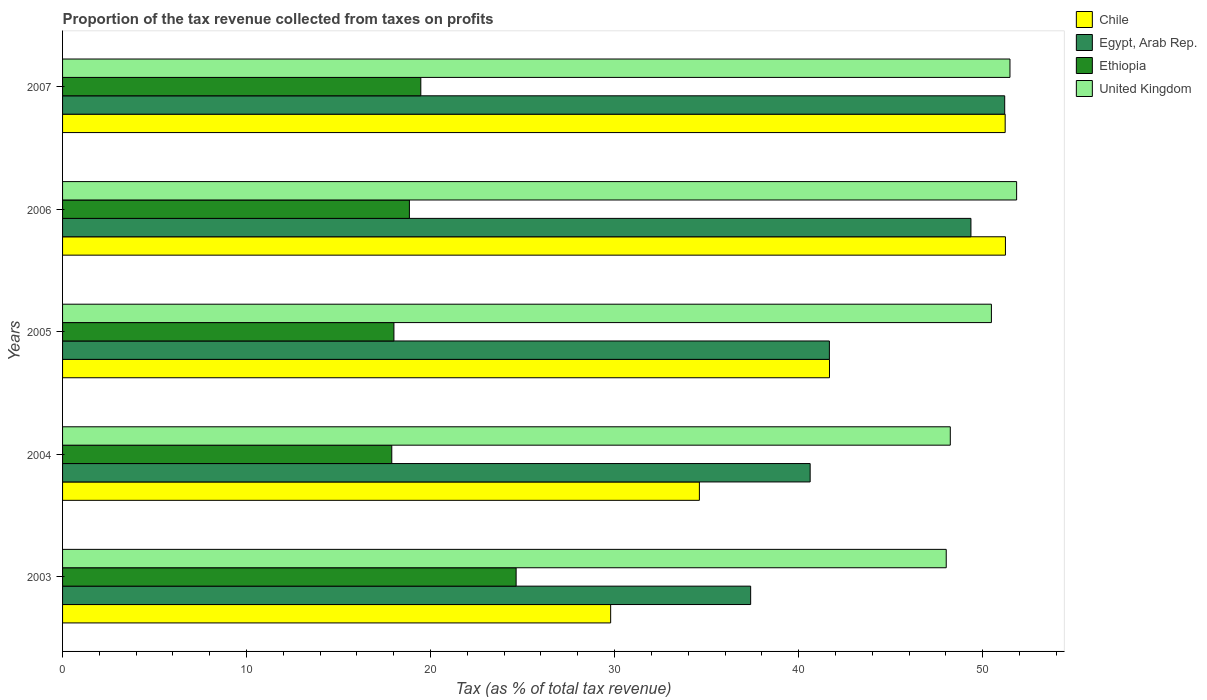How many groups of bars are there?
Your response must be concise. 5. Are the number of bars per tick equal to the number of legend labels?
Provide a short and direct response. Yes. Are the number of bars on each tick of the Y-axis equal?
Offer a terse response. Yes. How many bars are there on the 1st tick from the top?
Your response must be concise. 4. How many bars are there on the 2nd tick from the bottom?
Give a very brief answer. 4. What is the label of the 3rd group of bars from the top?
Make the answer very short. 2005. In how many cases, is the number of bars for a given year not equal to the number of legend labels?
Offer a terse response. 0. What is the proportion of the tax revenue collected in Egypt, Arab Rep. in 2004?
Offer a very short reply. 40.63. Across all years, what is the maximum proportion of the tax revenue collected in Ethiopia?
Offer a very short reply. 24.65. Across all years, what is the minimum proportion of the tax revenue collected in United Kingdom?
Offer a terse response. 48.02. In which year was the proportion of the tax revenue collected in United Kingdom minimum?
Provide a short and direct response. 2003. What is the total proportion of the tax revenue collected in Egypt, Arab Rep. in the graph?
Your response must be concise. 220.26. What is the difference between the proportion of the tax revenue collected in Egypt, Arab Rep. in 2003 and that in 2007?
Provide a short and direct response. -13.81. What is the difference between the proportion of the tax revenue collected in Chile in 2004 and the proportion of the tax revenue collected in Ethiopia in 2006?
Provide a succinct answer. 15.76. What is the average proportion of the tax revenue collected in Ethiopia per year?
Provide a short and direct response. 19.77. In the year 2005, what is the difference between the proportion of the tax revenue collected in Chile and proportion of the tax revenue collected in Egypt, Arab Rep.?
Provide a short and direct response. 0. What is the ratio of the proportion of the tax revenue collected in Chile in 2004 to that in 2006?
Give a very brief answer. 0.68. What is the difference between the highest and the second highest proportion of the tax revenue collected in United Kingdom?
Offer a terse response. 0.36. What is the difference between the highest and the lowest proportion of the tax revenue collected in Egypt, Arab Rep.?
Provide a short and direct response. 13.81. Is the sum of the proportion of the tax revenue collected in Egypt, Arab Rep. in 2003 and 2004 greater than the maximum proportion of the tax revenue collected in United Kingdom across all years?
Your answer should be compact. Yes. What does the 2nd bar from the top in 2006 represents?
Ensure brevity in your answer.  Ethiopia. Is it the case that in every year, the sum of the proportion of the tax revenue collected in Egypt, Arab Rep. and proportion of the tax revenue collected in United Kingdom is greater than the proportion of the tax revenue collected in Chile?
Offer a terse response. Yes. How many bars are there?
Offer a terse response. 20. Are all the bars in the graph horizontal?
Your response must be concise. Yes. What is the difference between two consecutive major ticks on the X-axis?
Keep it short and to the point. 10. How many legend labels are there?
Give a very brief answer. 4. How are the legend labels stacked?
Provide a succinct answer. Vertical. What is the title of the graph?
Offer a terse response. Proportion of the tax revenue collected from taxes on profits. What is the label or title of the X-axis?
Your answer should be very brief. Tax (as % of total tax revenue). What is the Tax (as % of total tax revenue) in Chile in 2003?
Your response must be concise. 29.79. What is the Tax (as % of total tax revenue) of Egypt, Arab Rep. in 2003?
Your answer should be compact. 37.39. What is the Tax (as % of total tax revenue) of Ethiopia in 2003?
Ensure brevity in your answer.  24.65. What is the Tax (as % of total tax revenue) of United Kingdom in 2003?
Keep it short and to the point. 48.02. What is the Tax (as % of total tax revenue) of Chile in 2004?
Ensure brevity in your answer.  34.61. What is the Tax (as % of total tax revenue) of Egypt, Arab Rep. in 2004?
Your answer should be very brief. 40.63. What is the Tax (as % of total tax revenue) in Ethiopia in 2004?
Your answer should be compact. 17.89. What is the Tax (as % of total tax revenue) in United Kingdom in 2004?
Provide a short and direct response. 48.24. What is the Tax (as % of total tax revenue) of Chile in 2005?
Offer a terse response. 41.68. What is the Tax (as % of total tax revenue) of Egypt, Arab Rep. in 2005?
Make the answer very short. 41.67. What is the Tax (as % of total tax revenue) of Ethiopia in 2005?
Provide a short and direct response. 18.01. What is the Tax (as % of total tax revenue) in United Kingdom in 2005?
Your response must be concise. 50.48. What is the Tax (as % of total tax revenue) in Chile in 2006?
Make the answer very short. 51.24. What is the Tax (as % of total tax revenue) in Egypt, Arab Rep. in 2006?
Your answer should be very brief. 49.37. What is the Tax (as % of total tax revenue) of Ethiopia in 2006?
Offer a very short reply. 18.85. What is the Tax (as % of total tax revenue) of United Kingdom in 2006?
Make the answer very short. 51.85. What is the Tax (as % of total tax revenue) of Chile in 2007?
Offer a very short reply. 51.23. What is the Tax (as % of total tax revenue) of Egypt, Arab Rep. in 2007?
Provide a succinct answer. 51.2. What is the Tax (as % of total tax revenue) of Ethiopia in 2007?
Your response must be concise. 19.47. What is the Tax (as % of total tax revenue) in United Kingdom in 2007?
Provide a short and direct response. 51.49. Across all years, what is the maximum Tax (as % of total tax revenue) in Chile?
Give a very brief answer. 51.24. Across all years, what is the maximum Tax (as % of total tax revenue) in Egypt, Arab Rep.?
Ensure brevity in your answer.  51.2. Across all years, what is the maximum Tax (as % of total tax revenue) in Ethiopia?
Ensure brevity in your answer.  24.65. Across all years, what is the maximum Tax (as % of total tax revenue) of United Kingdom?
Offer a very short reply. 51.85. Across all years, what is the minimum Tax (as % of total tax revenue) in Chile?
Give a very brief answer. 29.79. Across all years, what is the minimum Tax (as % of total tax revenue) in Egypt, Arab Rep.?
Keep it short and to the point. 37.39. Across all years, what is the minimum Tax (as % of total tax revenue) in Ethiopia?
Your response must be concise. 17.89. Across all years, what is the minimum Tax (as % of total tax revenue) of United Kingdom?
Ensure brevity in your answer.  48.02. What is the total Tax (as % of total tax revenue) in Chile in the graph?
Keep it short and to the point. 208.54. What is the total Tax (as % of total tax revenue) in Egypt, Arab Rep. in the graph?
Your answer should be compact. 220.26. What is the total Tax (as % of total tax revenue) of Ethiopia in the graph?
Offer a terse response. 98.86. What is the total Tax (as % of total tax revenue) in United Kingdom in the graph?
Your response must be concise. 250.08. What is the difference between the Tax (as % of total tax revenue) of Chile in 2003 and that in 2004?
Provide a succinct answer. -4.82. What is the difference between the Tax (as % of total tax revenue) of Egypt, Arab Rep. in 2003 and that in 2004?
Give a very brief answer. -3.23. What is the difference between the Tax (as % of total tax revenue) in Ethiopia in 2003 and that in 2004?
Your answer should be compact. 6.76. What is the difference between the Tax (as % of total tax revenue) of United Kingdom in 2003 and that in 2004?
Offer a very short reply. -0.22. What is the difference between the Tax (as % of total tax revenue) of Chile in 2003 and that in 2005?
Keep it short and to the point. -11.89. What is the difference between the Tax (as % of total tax revenue) in Egypt, Arab Rep. in 2003 and that in 2005?
Give a very brief answer. -4.28. What is the difference between the Tax (as % of total tax revenue) in Ethiopia in 2003 and that in 2005?
Keep it short and to the point. 6.64. What is the difference between the Tax (as % of total tax revenue) of United Kingdom in 2003 and that in 2005?
Your answer should be compact. -2.46. What is the difference between the Tax (as % of total tax revenue) of Chile in 2003 and that in 2006?
Offer a very short reply. -21.45. What is the difference between the Tax (as % of total tax revenue) in Egypt, Arab Rep. in 2003 and that in 2006?
Make the answer very short. -11.97. What is the difference between the Tax (as % of total tax revenue) in Ethiopia in 2003 and that in 2006?
Your response must be concise. 5.8. What is the difference between the Tax (as % of total tax revenue) of United Kingdom in 2003 and that in 2006?
Provide a short and direct response. -3.83. What is the difference between the Tax (as % of total tax revenue) of Chile in 2003 and that in 2007?
Give a very brief answer. -21.44. What is the difference between the Tax (as % of total tax revenue) in Egypt, Arab Rep. in 2003 and that in 2007?
Your answer should be compact. -13.81. What is the difference between the Tax (as % of total tax revenue) in Ethiopia in 2003 and that in 2007?
Give a very brief answer. 5.18. What is the difference between the Tax (as % of total tax revenue) of United Kingdom in 2003 and that in 2007?
Offer a terse response. -3.46. What is the difference between the Tax (as % of total tax revenue) of Chile in 2004 and that in 2005?
Make the answer very short. -7.07. What is the difference between the Tax (as % of total tax revenue) in Egypt, Arab Rep. in 2004 and that in 2005?
Offer a terse response. -1.05. What is the difference between the Tax (as % of total tax revenue) of Ethiopia in 2004 and that in 2005?
Offer a very short reply. -0.12. What is the difference between the Tax (as % of total tax revenue) of United Kingdom in 2004 and that in 2005?
Offer a terse response. -2.23. What is the difference between the Tax (as % of total tax revenue) of Chile in 2004 and that in 2006?
Offer a very short reply. -16.63. What is the difference between the Tax (as % of total tax revenue) of Egypt, Arab Rep. in 2004 and that in 2006?
Give a very brief answer. -8.74. What is the difference between the Tax (as % of total tax revenue) of Ethiopia in 2004 and that in 2006?
Offer a terse response. -0.96. What is the difference between the Tax (as % of total tax revenue) in United Kingdom in 2004 and that in 2006?
Provide a short and direct response. -3.61. What is the difference between the Tax (as % of total tax revenue) of Chile in 2004 and that in 2007?
Your answer should be compact. -16.62. What is the difference between the Tax (as % of total tax revenue) in Egypt, Arab Rep. in 2004 and that in 2007?
Offer a very short reply. -10.57. What is the difference between the Tax (as % of total tax revenue) of Ethiopia in 2004 and that in 2007?
Provide a succinct answer. -1.58. What is the difference between the Tax (as % of total tax revenue) of United Kingdom in 2004 and that in 2007?
Your response must be concise. -3.24. What is the difference between the Tax (as % of total tax revenue) in Chile in 2005 and that in 2006?
Keep it short and to the point. -9.56. What is the difference between the Tax (as % of total tax revenue) in Egypt, Arab Rep. in 2005 and that in 2006?
Offer a very short reply. -7.69. What is the difference between the Tax (as % of total tax revenue) of Ethiopia in 2005 and that in 2006?
Your answer should be very brief. -0.84. What is the difference between the Tax (as % of total tax revenue) in United Kingdom in 2005 and that in 2006?
Make the answer very short. -1.37. What is the difference between the Tax (as % of total tax revenue) in Chile in 2005 and that in 2007?
Provide a succinct answer. -9.55. What is the difference between the Tax (as % of total tax revenue) of Egypt, Arab Rep. in 2005 and that in 2007?
Provide a succinct answer. -9.53. What is the difference between the Tax (as % of total tax revenue) in Ethiopia in 2005 and that in 2007?
Make the answer very short. -1.46. What is the difference between the Tax (as % of total tax revenue) in United Kingdom in 2005 and that in 2007?
Give a very brief answer. -1.01. What is the difference between the Tax (as % of total tax revenue) of Chile in 2006 and that in 2007?
Provide a short and direct response. 0.01. What is the difference between the Tax (as % of total tax revenue) of Egypt, Arab Rep. in 2006 and that in 2007?
Give a very brief answer. -1.84. What is the difference between the Tax (as % of total tax revenue) in Ethiopia in 2006 and that in 2007?
Your answer should be very brief. -0.62. What is the difference between the Tax (as % of total tax revenue) of United Kingdom in 2006 and that in 2007?
Your answer should be compact. 0.36. What is the difference between the Tax (as % of total tax revenue) of Chile in 2003 and the Tax (as % of total tax revenue) of Egypt, Arab Rep. in 2004?
Make the answer very short. -10.84. What is the difference between the Tax (as % of total tax revenue) in Chile in 2003 and the Tax (as % of total tax revenue) in Ethiopia in 2004?
Provide a succinct answer. 11.89. What is the difference between the Tax (as % of total tax revenue) of Chile in 2003 and the Tax (as % of total tax revenue) of United Kingdom in 2004?
Your answer should be very brief. -18.46. What is the difference between the Tax (as % of total tax revenue) of Egypt, Arab Rep. in 2003 and the Tax (as % of total tax revenue) of Ethiopia in 2004?
Make the answer very short. 19.5. What is the difference between the Tax (as % of total tax revenue) of Egypt, Arab Rep. in 2003 and the Tax (as % of total tax revenue) of United Kingdom in 2004?
Provide a succinct answer. -10.85. What is the difference between the Tax (as % of total tax revenue) of Ethiopia in 2003 and the Tax (as % of total tax revenue) of United Kingdom in 2004?
Offer a terse response. -23.6. What is the difference between the Tax (as % of total tax revenue) of Chile in 2003 and the Tax (as % of total tax revenue) of Egypt, Arab Rep. in 2005?
Your answer should be very brief. -11.89. What is the difference between the Tax (as % of total tax revenue) in Chile in 2003 and the Tax (as % of total tax revenue) in Ethiopia in 2005?
Offer a very short reply. 11.78. What is the difference between the Tax (as % of total tax revenue) of Chile in 2003 and the Tax (as % of total tax revenue) of United Kingdom in 2005?
Keep it short and to the point. -20.69. What is the difference between the Tax (as % of total tax revenue) in Egypt, Arab Rep. in 2003 and the Tax (as % of total tax revenue) in Ethiopia in 2005?
Give a very brief answer. 19.39. What is the difference between the Tax (as % of total tax revenue) of Egypt, Arab Rep. in 2003 and the Tax (as % of total tax revenue) of United Kingdom in 2005?
Your answer should be very brief. -13.08. What is the difference between the Tax (as % of total tax revenue) in Ethiopia in 2003 and the Tax (as % of total tax revenue) in United Kingdom in 2005?
Your response must be concise. -25.83. What is the difference between the Tax (as % of total tax revenue) of Chile in 2003 and the Tax (as % of total tax revenue) of Egypt, Arab Rep. in 2006?
Your answer should be compact. -19.58. What is the difference between the Tax (as % of total tax revenue) of Chile in 2003 and the Tax (as % of total tax revenue) of Ethiopia in 2006?
Make the answer very short. 10.94. What is the difference between the Tax (as % of total tax revenue) of Chile in 2003 and the Tax (as % of total tax revenue) of United Kingdom in 2006?
Make the answer very short. -22.06. What is the difference between the Tax (as % of total tax revenue) of Egypt, Arab Rep. in 2003 and the Tax (as % of total tax revenue) of Ethiopia in 2006?
Your answer should be compact. 18.55. What is the difference between the Tax (as % of total tax revenue) in Egypt, Arab Rep. in 2003 and the Tax (as % of total tax revenue) in United Kingdom in 2006?
Offer a terse response. -14.45. What is the difference between the Tax (as % of total tax revenue) in Ethiopia in 2003 and the Tax (as % of total tax revenue) in United Kingdom in 2006?
Ensure brevity in your answer.  -27.2. What is the difference between the Tax (as % of total tax revenue) of Chile in 2003 and the Tax (as % of total tax revenue) of Egypt, Arab Rep. in 2007?
Ensure brevity in your answer.  -21.41. What is the difference between the Tax (as % of total tax revenue) of Chile in 2003 and the Tax (as % of total tax revenue) of Ethiopia in 2007?
Your answer should be very brief. 10.32. What is the difference between the Tax (as % of total tax revenue) of Chile in 2003 and the Tax (as % of total tax revenue) of United Kingdom in 2007?
Keep it short and to the point. -21.7. What is the difference between the Tax (as % of total tax revenue) in Egypt, Arab Rep. in 2003 and the Tax (as % of total tax revenue) in Ethiopia in 2007?
Your answer should be very brief. 17.93. What is the difference between the Tax (as % of total tax revenue) of Egypt, Arab Rep. in 2003 and the Tax (as % of total tax revenue) of United Kingdom in 2007?
Offer a very short reply. -14.09. What is the difference between the Tax (as % of total tax revenue) in Ethiopia in 2003 and the Tax (as % of total tax revenue) in United Kingdom in 2007?
Your answer should be very brief. -26.84. What is the difference between the Tax (as % of total tax revenue) of Chile in 2004 and the Tax (as % of total tax revenue) of Egypt, Arab Rep. in 2005?
Make the answer very short. -7.06. What is the difference between the Tax (as % of total tax revenue) in Chile in 2004 and the Tax (as % of total tax revenue) in Ethiopia in 2005?
Provide a short and direct response. 16.6. What is the difference between the Tax (as % of total tax revenue) of Chile in 2004 and the Tax (as % of total tax revenue) of United Kingdom in 2005?
Ensure brevity in your answer.  -15.87. What is the difference between the Tax (as % of total tax revenue) in Egypt, Arab Rep. in 2004 and the Tax (as % of total tax revenue) in Ethiopia in 2005?
Your answer should be compact. 22.62. What is the difference between the Tax (as % of total tax revenue) in Egypt, Arab Rep. in 2004 and the Tax (as % of total tax revenue) in United Kingdom in 2005?
Ensure brevity in your answer.  -9.85. What is the difference between the Tax (as % of total tax revenue) of Ethiopia in 2004 and the Tax (as % of total tax revenue) of United Kingdom in 2005?
Ensure brevity in your answer.  -32.59. What is the difference between the Tax (as % of total tax revenue) of Chile in 2004 and the Tax (as % of total tax revenue) of Egypt, Arab Rep. in 2006?
Ensure brevity in your answer.  -14.76. What is the difference between the Tax (as % of total tax revenue) of Chile in 2004 and the Tax (as % of total tax revenue) of Ethiopia in 2006?
Your answer should be very brief. 15.76. What is the difference between the Tax (as % of total tax revenue) in Chile in 2004 and the Tax (as % of total tax revenue) in United Kingdom in 2006?
Give a very brief answer. -17.24. What is the difference between the Tax (as % of total tax revenue) of Egypt, Arab Rep. in 2004 and the Tax (as % of total tax revenue) of Ethiopia in 2006?
Offer a terse response. 21.78. What is the difference between the Tax (as % of total tax revenue) in Egypt, Arab Rep. in 2004 and the Tax (as % of total tax revenue) in United Kingdom in 2006?
Your answer should be very brief. -11.22. What is the difference between the Tax (as % of total tax revenue) of Ethiopia in 2004 and the Tax (as % of total tax revenue) of United Kingdom in 2006?
Keep it short and to the point. -33.96. What is the difference between the Tax (as % of total tax revenue) in Chile in 2004 and the Tax (as % of total tax revenue) in Egypt, Arab Rep. in 2007?
Offer a terse response. -16.59. What is the difference between the Tax (as % of total tax revenue) in Chile in 2004 and the Tax (as % of total tax revenue) in Ethiopia in 2007?
Make the answer very short. 15.14. What is the difference between the Tax (as % of total tax revenue) in Chile in 2004 and the Tax (as % of total tax revenue) in United Kingdom in 2007?
Your response must be concise. -16.88. What is the difference between the Tax (as % of total tax revenue) in Egypt, Arab Rep. in 2004 and the Tax (as % of total tax revenue) in Ethiopia in 2007?
Provide a short and direct response. 21.16. What is the difference between the Tax (as % of total tax revenue) in Egypt, Arab Rep. in 2004 and the Tax (as % of total tax revenue) in United Kingdom in 2007?
Ensure brevity in your answer.  -10.86. What is the difference between the Tax (as % of total tax revenue) of Ethiopia in 2004 and the Tax (as % of total tax revenue) of United Kingdom in 2007?
Make the answer very short. -33.59. What is the difference between the Tax (as % of total tax revenue) in Chile in 2005 and the Tax (as % of total tax revenue) in Egypt, Arab Rep. in 2006?
Ensure brevity in your answer.  -7.69. What is the difference between the Tax (as % of total tax revenue) in Chile in 2005 and the Tax (as % of total tax revenue) in Ethiopia in 2006?
Provide a succinct answer. 22.83. What is the difference between the Tax (as % of total tax revenue) in Chile in 2005 and the Tax (as % of total tax revenue) in United Kingdom in 2006?
Offer a terse response. -10.17. What is the difference between the Tax (as % of total tax revenue) in Egypt, Arab Rep. in 2005 and the Tax (as % of total tax revenue) in Ethiopia in 2006?
Your answer should be very brief. 22.82. What is the difference between the Tax (as % of total tax revenue) in Egypt, Arab Rep. in 2005 and the Tax (as % of total tax revenue) in United Kingdom in 2006?
Ensure brevity in your answer.  -10.18. What is the difference between the Tax (as % of total tax revenue) of Ethiopia in 2005 and the Tax (as % of total tax revenue) of United Kingdom in 2006?
Provide a short and direct response. -33.84. What is the difference between the Tax (as % of total tax revenue) of Chile in 2005 and the Tax (as % of total tax revenue) of Egypt, Arab Rep. in 2007?
Offer a very short reply. -9.52. What is the difference between the Tax (as % of total tax revenue) in Chile in 2005 and the Tax (as % of total tax revenue) in Ethiopia in 2007?
Your response must be concise. 22.21. What is the difference between the Tax (as % of total tax revenue) of Chile in 2005 and the Tax (as % of total tax revenue) of United Kingdom in 2007?
Keep it short and to the point. -9.81. What is the difference between the Tax (as % of total tax revenue) in Egypt, Arab Rep. in 2005 and the Tax (as % of total tax revenue) in Ethiopia in 2007?
Offer a terse response. 22.2. What is the difference between the Tax (as % of total tax revenue) in Egypt, Arab Rep. in 2005 and the Tax (as % of total tax revenue) in United Kingdom in 2007?
Give a very brief answer. -9.81. What is the difference between the Tax (as % of total tax revenue) of Ethiopia in 2005 and the Tax (as % of total tax revenue) of United Kingdom in 2007?
Offer a terse response. -33.48. What is the difference between the Tax (as % of total tax revenue) in Chile in 2006 and the Tax (as % of total tax revenue) in Egypt, Arab Rep. in 2007?
Keep it short and to the point. 0.04. What is the difference between the Tax (as % of total tax revenue) in Chile in 2006 and the Tax (as % of total tax revenue) in Ethiopia in 2007?
Ensure brevity in your answer.  31.77. What is the difference between the Tax (as % of total tax revenue) in Chile in 2006 and the Tax (as % of total tax revenue) in United Kingdom in 2007?
Provide a short and direct response. -0.25. What is the difference between the Tax (as % of total tax revenue) of Egypt, Arab Rep. in 2006 and the Tax (as % of total tax revenue) of Ethiopia in 2007?
Provide a succinct answer. 29.9. What is the difference between the Tax (as % of total tax revenue) in Egypt, Arab Rep. in 2006 and the Tax (as % of total tax revenue) in United Kingdom in 2007?
Provide a short and direct response. -2.12. What is the difference between the Tax (as % of total tax revenue) in Ethiopia in 2006 and the Tax (as % of total tax revenue) in United Kingdom in 2007?
Provide a succinct answer. -32.64. What is the average Tax (as % of total tax revenue) in Chile per year?
Provide a succinct answer. 41.71. What is the average Tax (as % of total tax revenue) in Egypt, Arab Rep. per year?
Give a very brief answer. 44.05. What is the average Tax (as % of total tax revenue) of Ethiopia per year?
Your response must be concise. 19.77. What is the average Tax (as % of total tax revenue) in United Kingdom per year?
Offer a very short reply. 50.02. In the year 2003, what is the difference between the Tax (as % of total tax revenue) in Chile and Tax (as % of total tax revenue) in Egypt, Arab Rep.?
Offer a terse response. -7.61. In the year 2003, what is the difference between the Tax (as % of total tax revenue) of Chile and Tax (as % of total tax revenue) of Ethiopia?
Your response must be concise. 5.14. In the year 2003, what is the difference between the Tax (as % of total tax revenue) in Chile and Tax (as % of total tax revenue) in United Kingdom?
Offer a terse response. -18.24. In the year 2003, what is the difference between the Tax (as % of total tax revenue) of Egypt, Arab Rep. and Tax (as % of total tax revenue) of Ethiopia?
Keep it short and to the point. 12.75. In the year 2003, what is the difference between the Tax (as % of total tax revenue) in Egypt, Arab Rep. and Tax (as % of total tax revenue) in United Kingdom?
Your answer should be very brief. -10.63. In the year 2003, what is the difference between the Tax (as % of total tax revenue) of Ethiopia and Tax (as % of total tax revenue) of United Kingdom?
Your response must be concise. -23.37. In the year 2004, what is the difference between the Tax (as % of total tax revenue) of Chile and Tax (as % of total tax revenue) of Egypt, Arab Rep.?
Make the answer very short. -6.02. In the year 2004, what is the difference between the Tax (as % of total tax revenue) in Chile and Tax (as % of total tax revenue) in Ethiopia?
Ensure brevity in your answer.  16.72. In the year 2004, what is the difference between the Tax (as % of total tax revenue) of Chile and Tax (as % of total tax revenue) of United Kingdom?
Provide a short and direct response. -13.64. In the year 2004, what is the difference between the Tax (as % of total tax revenue) in Egypt, Arab Rep. and Tax (as % of total tax revenue) in Ethiopia?
Make the answer very short. 22.74. In the year 2004, what is the difference between the Tax (as % of total tax revenue) in Egypt, Arab Rep. and Tax (as % of total tax revenue) in United Kingdom?
Offer a very short reply. -7.62. In the year 2004, what is the difference between the Tax (as % of total tax revenue) of Ethiopia and Tax (as % of total tax revenue) of United Kingdom?
Your response must be concise. -30.35. In the year 2005, what is the difference between the Tax (as % of total tax revenue) of Chile and Tax (as % of total tax revenue) of Egypt, Arab Rep.?
Provide a short and direct response. 0.01. In the year 2005, what is the difference between the Tax (as % of total tax revenue) in Chile and Tax (as % of total tax revenue) in Ethiopia?
Provide a succinct answer. 23.67. In the year 2005, what is the difference between the Tax (as % of total tax revenue) in Chile and Tax (as % of total tax revenue) in United Kingdom?
Make the answer very short. -8.8. In the year 2005, what is the difference between the Tax (as % of total tax revenue) of Egypt, Arab Rep. and Tax (as % of total tax revenue) of Ethiopia?
Your answer should be compact. 23.67. In the year 2005, what is the difference between the Tax (as % of total tax revenue) of Egypt, Arab Rep. and Tax (as % of total tax revenue) of United Kingdom?
Make the answer very short. -8.8. In the year 2005, what is the difference between the Tax (as % of total tax revenue) of Ethiopia and Tax (as % of total tax revenue) of United Kingdom?
Your answer should be very brief. -32.47. In the year 2006, what is the difference between the Tax (as % of total tax revenue) of Chile and Tax (as % of total tax revenue) of Egypt, Arab Rep.?
Provide a short and direct response. 1.88. In the year 2006, what is the difference between the Tax (as % of total tax revenue) in Chile and Tax (as % of total tax revenue) in Ethiopia?
Ensure brevity in your answer.  32.39. In the year 2006, what is the difference between the Tax (as % of total tax revenue) in Chile and Tax (as % of total tax revenue) in United Kingdom?
Your answer should be very brief. -0.61. In the year 2006, what is the difference between the Tax (as % of total tax revenue) in Egypt, Arab Rep. and Tax (as % of total tax revenue) in Ethiopia?
Provide a short and direct response. 30.52. In the year 2006, what is the difference between the Tax (as % of total tax revenue) of Egypt, Arab Rep. and Tax (as % of total tax revenue) of United Kingdom?
Give a very brief answer. -2.48. In the year 2006, what is the difference between the Tax (as % of total tax revenue) in Ethiopia and Tax (as % of total tax revenue) in United Kingdom?
Make the answer very short. -33. In the year 2007, what is the difference between the Tax (as % of total tax revenue) in Chile and Tax (as % of total tax revenue) in Egypt, Arab Rep.?
Give a very brief answer. 0.03. In the year 2007, what is the difference between the Tax (as % of total tax revenue) of Chile and Tax (as % of total tax revenue) of Ethiopia?
Keep it short and to the point. 31.76. In the year 2007, what is the difference between the Tax (as % of total tax revenue) of Chile and Tax (as % of total tax revenue) of United Kingdom?
Your response must be concise. -0.26. In the year 2007, what is the difference between the Tax (as % of total tax revenue) of Egypt, Arab Rep. and Tax (as % of total tax revenue) of Ethiopia?
Keep it short and to the point. 31.73. In the year 2007, what is the difference between the Tax (as % of total tax revenue) in Egypt, Arab Rep. and Tax (as % of total tax revenue) in United Kingdom?
Make the answer very short. -0.29. In the year 2007, what is the difference between the Tax (as % of total tax revenue) of Ethiopia and Tax (as % of total tax revenue) of United Kingdom?
Ensure brevity in your answer.  -32.02. What is the ratio of the Tax (as % of total tax revenue) in Chile in 2003 to that in 2004?
Keep it short and to the point. 0.86. What is the ratio of the Tax (as % of total tax revenue) of Egypt, Arab Rep. in 2003 to that in 2004?
Your answer should be compact. 0.92. What is the ratio of the Tax (as % of total tax revenue) in Ethiopia in 2003 to that in 2004?
Provide a succinct answer. 1.38. What is the ratio of the Tax (as % of total tax revenue) of United Kingdom in 2003 to that in 2004?
Your response must be concise. 1. What is the ratio of the Tax (as % of total tax revenue) in Chile in 2003 to that in 2005?
Offer a very short reply. 0.71. What is the ratio of the Tax (as % of total tax revenue) in Egypt, Arab Rep. in 2003 to that in 2005?
Offer a terse response. 0.9. What is the ratio of the Tax (as % of total tax revenue) in Ethiopia in 2003 to that in 2005?
Make the answer very short. 1.37. What is the ratio of the Tax (as % of total tax revenue) of United Kingdom in 2003 to that in 2005?
Provide a succinct answer. 0.95. What is the ratio of the Tax (as % of total tax revenue) of Chile in 2003 to that in 2006?
Provide a short and direct response. 0.58. What is the ratio of the Tax (as % of total tax revenue) of Egypt, Arab Rep. in 2003 to that in 2006?
Keep it short and to the point. 0.76. What is the ratio of the Tax (as % of total tax revenue) of Ethiopia in 2003 to that in 2006?
Offer a very short reply. 1.31. What is the ratio of the Tax (as % of total tax revenue) in United Kingdom in 2003 to that in 2006?
Offer a terse response. 0.93. What is the ratio of the Tax (as % of total tax revenue) in Chile in 2003 to that in 2007?
Your response must be concise. 0.58. What is the ratio of the Tax (as % of total tax revenue) in Egypt, Arab Rep. in 2003 to that in 2007?
Your answer should be very brief. 0.73. What is the ratio of the Tax (as % of total tax revenue) of Ethiopia in 2003 to that in 2007?
Keep it short and to the point. 1.27. What is the ratio of the Tax (as % of total tax revenue) in United Kingdom in 2003 to that in 2007?
Provide a succinct answer. 0.93. What is the ratio of the Tax (as % of total tax revenue) of Chile in 2004 to that in 2005?
Make the answer very short. 0.83. What is the ratio of the Tax (as % of total tax revenue) in Egypt, Arab Rep. in 2004 to that in 2005?
Ensure brevity in your answer.  0.97. What is the ratio of the Tax (as % of total tax revenue) in United Kingdom in 2004 to that in 2005?
Ensure brevity in your answer.  0.96. What is the ratio of the Tax (as % of total tax revenue) in Chile in 2004 to that in 2006?
Make the answer very short. 0.68. What is the ratio of the Tax (as % of total tax revenue) in Egypt, Arab Rep. in 2004 to that in 2006?
Ensure brevity in your answer.  0.82. What is the ratio of the Tax (as % of total tax revenue) of Ethiopia in 2004 to that in 2006?
Your response must be concise. 0.95. What is the ratio of the Tax (as % of total tax revenue) in United Kingdom in 2004 to that in 2006?
Your answer should be very brief. 0.93. What is the ratio of the Tax (as % of total tax revenue) of Chile in 2004 to that in 2007?
Your response must be concise. 0.68. What is the ratio of the Tax (as % of total tax revenue) in Egypt, Arab Rep. in 2004 to that in 2007?
Keep it short and to the point. 0.79. What is the ratio of the Tax (as % of total tax revenue) in Ethiopia in 2004 to that in 2007?
Provide a short and direct response. 0.92. What is the ratio of the Tax (as % of total tax revenue) of United Kingdom in 2004 to that in 2007?
Give a very brief answer. 0.94. What is the ratio of the Tax (as % of total tax revenue) in Chile in 2005 to that in 2006?
Offer a very short reply. 0.81. What is the ratio of the Tax (as % of total tax revenue) in Egypt, Arab Rep. in 2005 to that in 2006?
Your answer should be compact. 0.84. What is the ratio of the Tax (as % of total tax revenue) in Ethiopia in 2005 to that in 2006?
Keep it short and to the point. 0.96. What is the ratio of the Tax (as % of total tax revenue) in United Kingdom in 2005 to that in 2006?
Ensure brevity in your answer.  0.97. What is the ratio of the Tax (as % of total tax revenue) in Chile in 2005 to that in 2007?
Make the answer very short. 0.81. What is the ratio of the Tax (as % of total tax revenue) in Egypt, Arab Rep. in 2005 to that in 2007?
Make the answer very short. 0.81. What is the ratio of the Tax (as % of total tax revenue) in Ethiopia in 2005 to that in 2007?
Ensure brevity in your answer.  0.93. What is the ratio of the Tax (as % of total tax revenue) of United Kingdom in 2005 to that in 2007?
Give a very brief answer. 0.98. What is the ratio of the Tax (as % of total tax revenue) of Chile in 2006 to that in 2007?
Make the answer very short. 1. What is the ratio of the Tax (as % of total tax revenue) of Egypt, Arab Rep. in 2006 to that in 2007?
Keep it short and to the point. 0.96. What is the ratio of the Tax (as % of total tax revenue) in Ethiopia in 2006 to that in 2007?
Provide a short and direct response. 0.97. What is the difference between the highest and the second highest Tax (as % of total tax revenue) of Chile?
Give a very brief answer. 0.01. What is the difference between the highest and the second highest Tax (as % of total tax revenue) in Egypt, Arab Rep.?
Provide a succinct answer. 1.84. What is the difference between the highest and the second highest Tax (as % of total tax revenue) in Ethiopia?
Offer a terse response. 5.18. What is the difference between the highest and the second highest Tax (as % of total tax revenue) of United Kingdom?
Keep it short and to the point. 0.36. What is the difference between the highest and the lowest Tax (as % of total tax revenue) of Chile?
Keep it short and to the point. 21.45. What is the difference between the highest and the lowest Tax (as % of total tax revenue) in Egypt, Arab Rep.?
Your response must be concise. 13.81. What is the difference between the highest and the lowest Tax (as % of total tax revenue) in Ethiopia?
Ensure brevity in your answer.  6.76. What is the difference between the highest and the lowest Tax (as % of total tax revenue) in United Kingdom?
Offer a terse response. 3.83. 